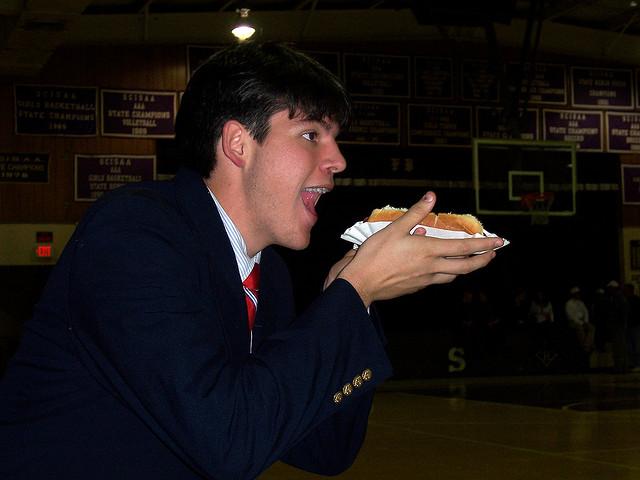What color is the man's jacket?
Be succinct. Blue. What is the man eating?
Concise answer only. Hot dog. Where is this man eating a hot dog?
Concise answer only. Outside. 